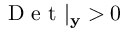Convert formula to latex. <formula><loc_0><loc_0><loc_500><loc_500>D e t | _ { y } > 0</formula> 